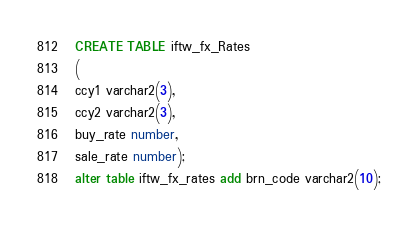<code> <loc_0><loc_0><loc_500><loc_500><_SQL_> CREATE TABLE iftw_fx_Rates
 (
 ccy1 varchar2(3),
 ccy2 varchar2(3),
 buy_rate number,
 sale_rate number);
 alter table iftw_fx_rates add brn_code varchar2(10);</code> 